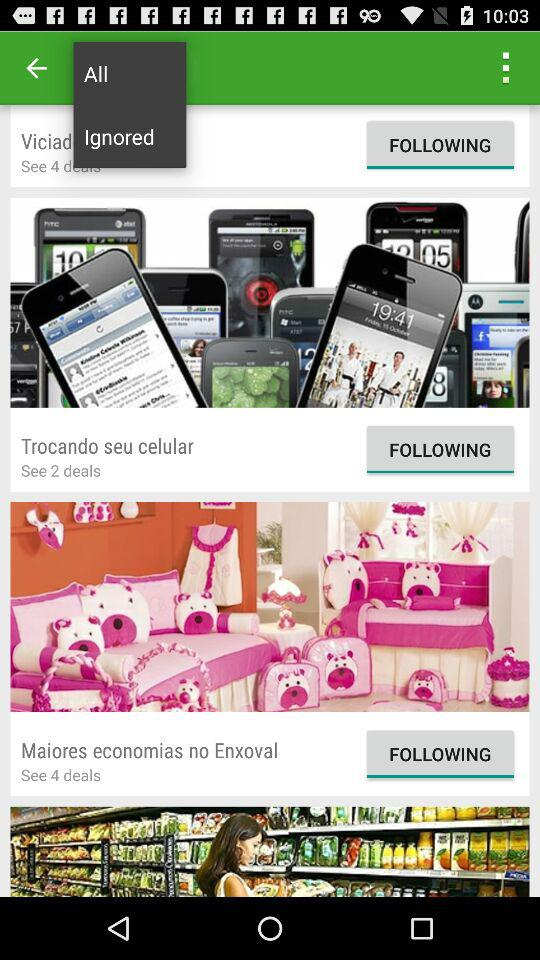How many deals are there in "Maiores economias no Enxoval"? There are 4 deals in "Maiores economias no Enxoval". 